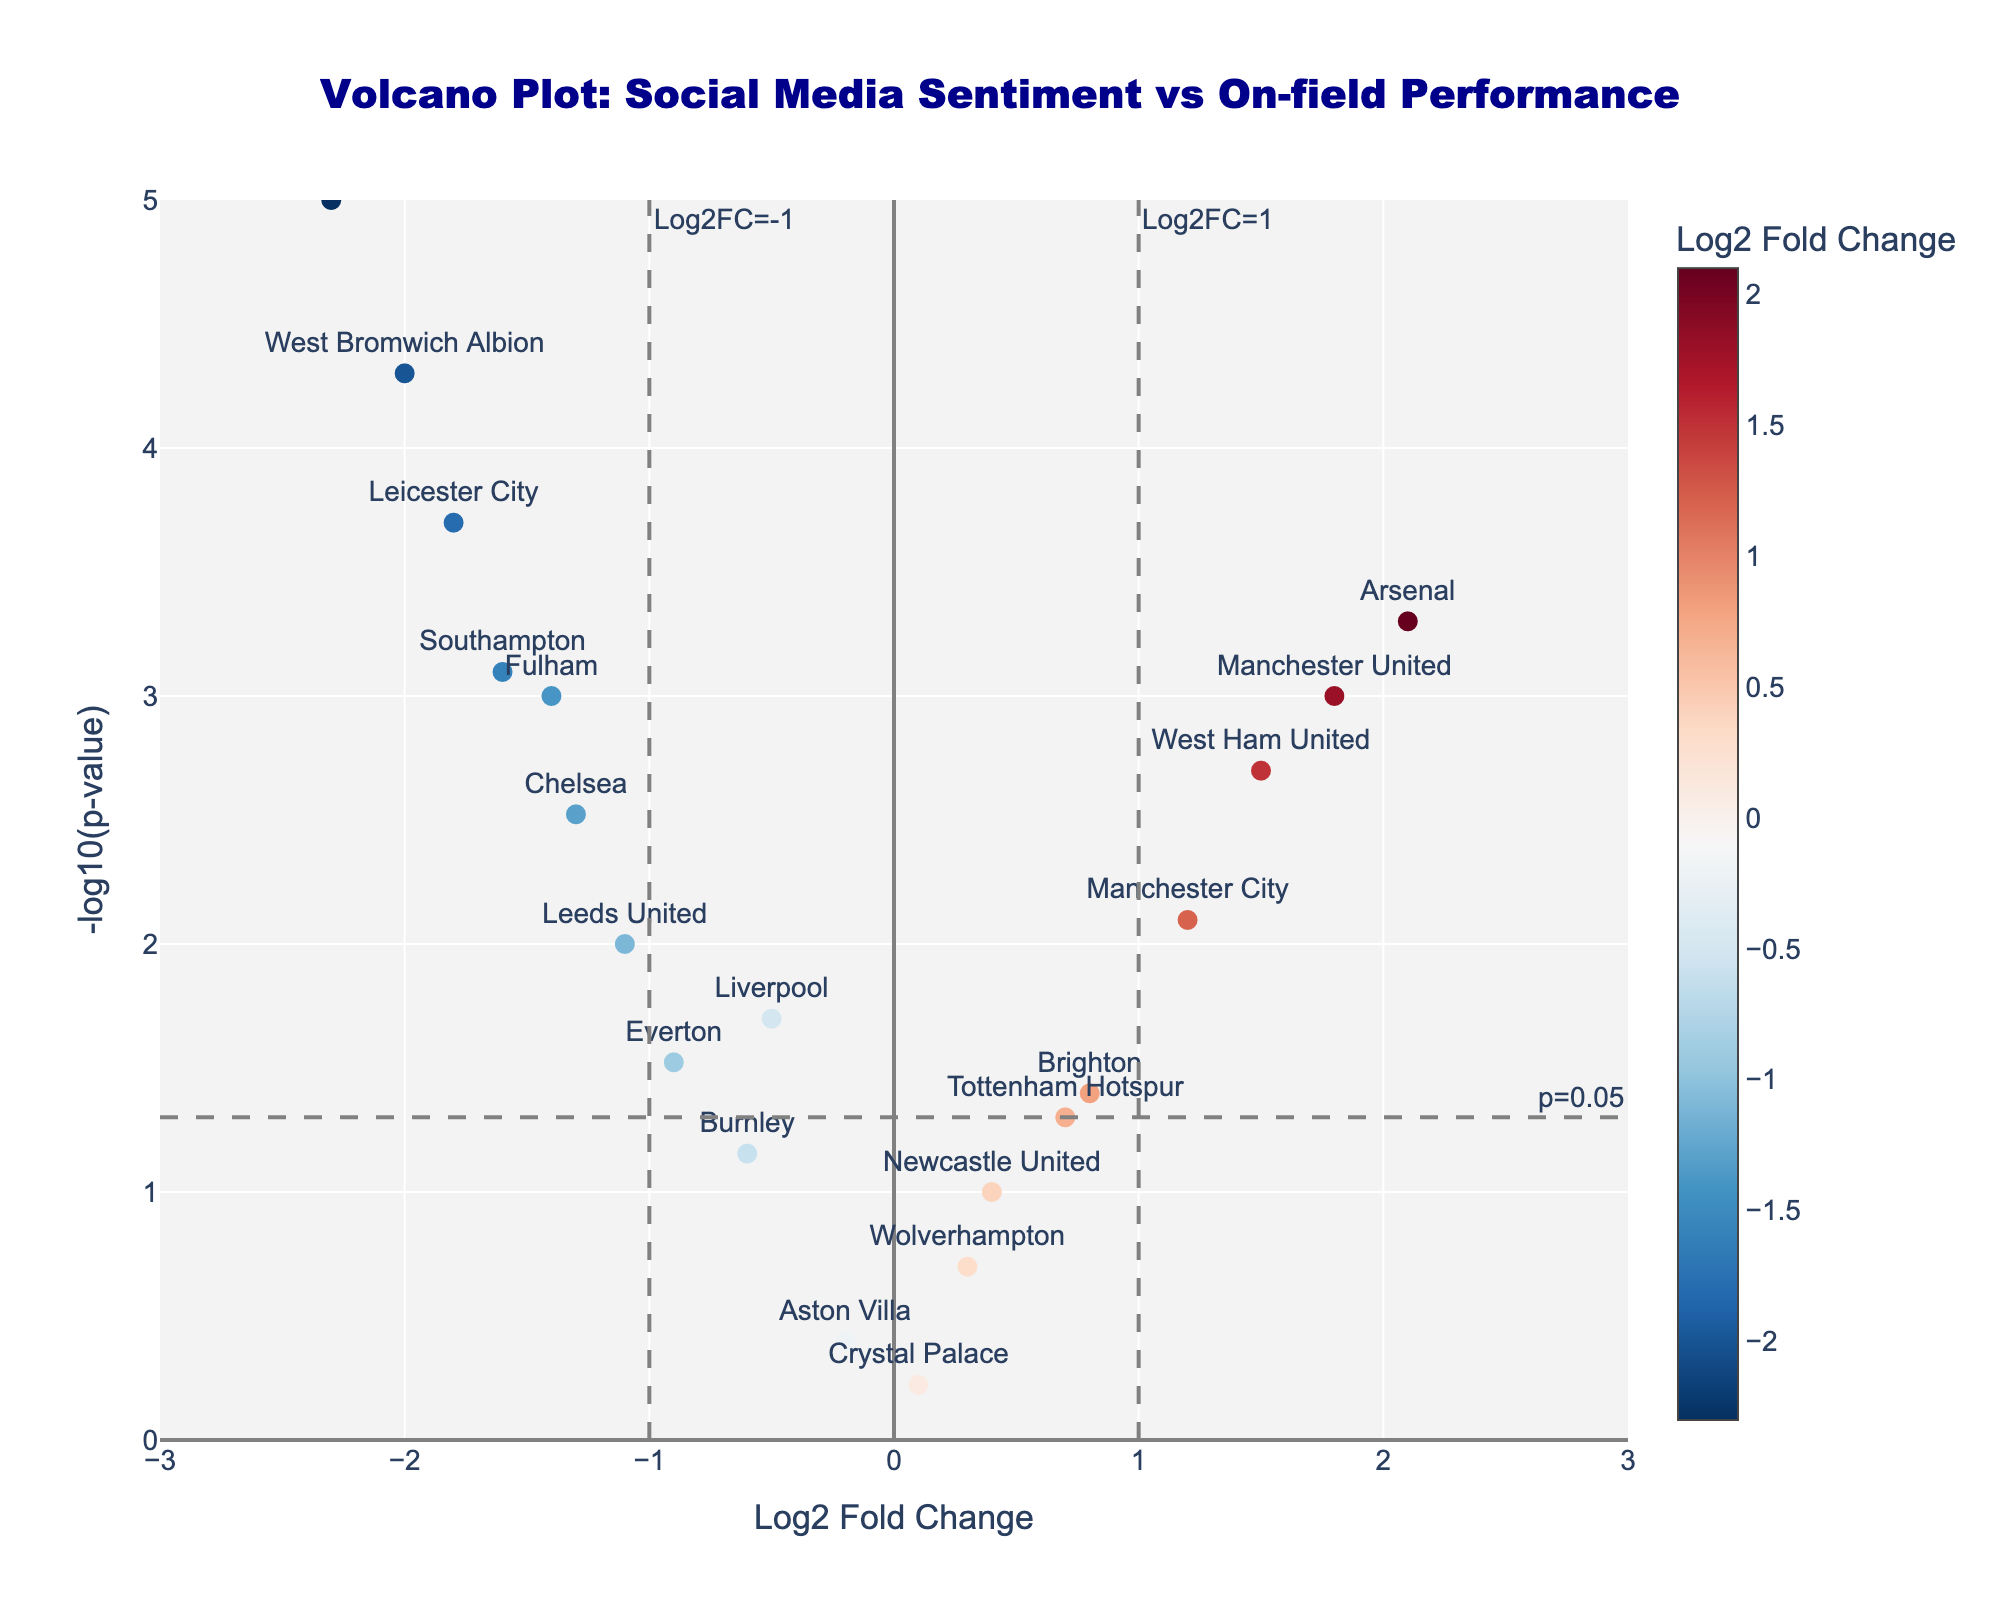What's the title of the figure? The title is usually located at the top of the figure. In this case, the title is "Volcano Plot: Social Media Sentiment vs On-field Performance".
Answer: Volcano Plot: Social Media Sentiment vs On-field Performance How many teams are plotted in the figure? Count the number of unique teams present in the data points. Each team corresponds to a scatter point. According to the data provided, there are 20 teams.
Answer: 20 Which team has the highest Log2 Fold Change? The team with the highest Log2 Fold Change will have the furthest point to the right on the x-axis. From the data, Arsenal has the highest Log2 Fold Change of 2.1.
Answer: Arsenal What does the y-axis represent? The y-axis label indicates what is being measured on the vertical axis. In this plot, the y-axis represents "-log10(p-value)".
Answer: -log10(p-value) Are there any teams with a Log2 Fold Change greater than 1 and a P-value less than 0.01? If yes, which ones? Identify the points in the figure that are to the right of the vertical line at Log2FC=1 and above the horizontal line at p-value=0.01 (-log10(p-value)=2). According to the data: Manchester United, Arsenal, Manchester City, and West Ham United meet these criteria.
Answer: Manchester United, Arsenal, Manchester City, West Ham United Which team shows the most negative sentiment according to Log2 Fold Change? The most negative sentiment will have the lowest Log2 Fold Change, which is the furthest point to the left on the x-axis. From the data, Sheffield United has the lowest Log2 Fold Change of -2.3.
Answer: Sheffield United What threshold values indicate statistical significance on the plot? The plot includes threshold lines to indicate statistical significance. The horizontal line marks p=0.05, and the vertical lines mark Log2FC=1 and Log2FC=-1. These values help determine significant changes.
Answer: p=0.05 and Log2FC=1, -1 If a team has a p-value of 0.05, what would be its corresponding y-axis value? Convert the p-value to the corresponding -log10(p-value). For p-value=0.05, -log10(0.05) equals approximately 1.30.
Answer: 1.30 Which team has the smallest p-value? What is its corresponding -log10(p-value) value? The smallest p-value is the one with the highest point on the y-axis. From the data, Sheffield United has the smallest p-value of 0.00001. The corresponding -log10(p-value) = -log10(0.00001) = 5.
Answer: Sheffield United, 5 What can be inferred about the teams with Log2 Fold Change close to 0? Teams with a Log2FC close to 0 indicate little to no change in sentiment. These points are near the center of the x-axis. Examples from the data include Wolverhampton (Log2FC=0.3) and Crystal Palace (Log2FC=0.1).
Answer: Little to no change in sentiment 